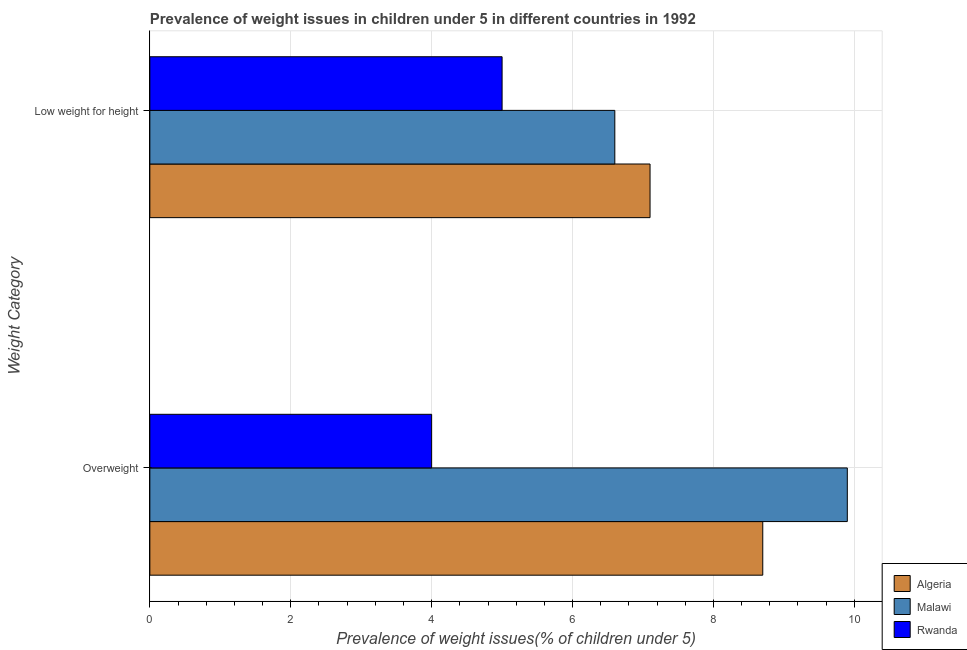How many different coloured bars are there?
Offer a terse response. 3. How many groups of bars are there?
Your answer should be very brief. 2. How many bars are there on the 2nd tick from the top?
Provide a succinct answer. 3. What is the label of the 1st group of bars from the top?
Provide a succinct answer. Low weight for height. What is the percentage of underweight children in Algeria?
Your answer should be compact. 7.1. Across all countries, what is the maximum percentage of underweight children?
Give a very brief answer. 7.1. Across all countries, what is the minimum percentage of overweight children?
Keep it short and to the point. 4. In which country was the percentage of underweight children maximum?
Offer a terse response. Algeria. In which country was the percentage of overweight children minimum?
Offer a terse response. Rwanda. What is the total percentage of underweight children in the graph?
Keep it short and to the point. 18.7. What is the difference between the percentage of overweight children in Rwanda and the percentage of underweight children in Algeria?
Keep it short and to the point. -3.1. What is the average percentage of underweight children per country?
Your answer should be very brief. 6.23. What is the difference between the percentage of overweight children and percentage of underweight children in Rwanda?
Give a very brief answer. -1. What is the ratio of the percentage of underweight children in Rwanda to that in Algeria?
Make the answer very short. 0.7. In how many countries, is the percentage of overweight children greater than the average percentage of overweight children taken over all countries?
Offer a very short reply. 2. What does the 3rd bar from the top in Overweight represents?
Your answer should be compact. Algeria. What does the 3rd bar from the bottom in Overweight represents?
Your answer should be very brief. Rwanda. What is the difference between two consecutive major ticks on the X-axis?
Provide a short and direct response. 2. How many legend labels are there?
Offer a terse response. 3. How are the legend labels stacked?
Offer a very short reply. Vertical. What is the title of the graph?
Your answer should be compact. Prevalence of weight issues in children under 5 in different countries in 1992. What is the label or title of the X-axis?
Keep it short and to the point. Prevalence of weight issues(% of children under 5). What is the label or title of the Y-axis?
Offer a very short reply. Weight Category. What is the Prevalence of weight issues(% of children under 5) of Algeria in Overweight?
Give a very brief answer. 8.7. What is the Prevalence of weight issues(% of children under 5) in Malawi in Overweight?
Keep it short and to the point. 9.9. What is the Prevalence of weight issues(% of children under 5) in Rwanda in Overweight?
Offer a very short reply. 4. What is the Prevalence of weight issues(% of children under 5) in Algeria in Low weight for height?
Provide a succinct answer. 7.1. What is the Prevalence of weight issues(% of children under 5) in Malawi in Low weight for height?
Your answer should be very brief. 6.6. Across all Weight Category, what is the maximum Prevalence of weight issues(% of children under 5) in Algeria?
Offer a very short reply. 8.7. Across all Weight Category, what is the maximum Prevalence of weight issues(% of children under 5) of Malawi?
Keep it short and to the point. 9.9. Across all Weight Category, what is the maximum Prevalence of weight issues(% of children under 5) in Rwanda?
Provide a succinct answer. 5. Across all Weight Category, what is the minimum Prevalence of weight issues(% of children under 5) in Algeria?
Your answer should be compact. 7.1. Across all Weight Category, what is the minimum Prevalence of weight issues(% of children under 5) of Malawi?
Make the answer very short. 6.6. Across all Weight Category, what is the minimum Prevalence of weight issues(% of children under 5) of Rwanda?
Your response must be concise. 4. What is the total Prevalence of weight issues(% of children under 5) of Algeria in the graph?
Offer a terse response. 15.8. What is the total Prevalence of weight issues(% of children under 5) of Malawi in the graph?
Offer a very short reply. 16.5. What is the total Prevalence of weight issues(% of children under 5) in Rwanda in the graph?
Your answer should be very brief. 9. What is the difference between the Prevalence of weight issues(% of children under 5) in Algeria in Overweight and that in Low weight for height?
Your answer should be very brief. 1.6. What is the difference between the Prevalence of weight issues(% of children under 5) in Malawi in Overweight and that in Low weight for height?
Provide a succinct answer. 3.3. What is the difference between the Prevalence of weight issues(% of children under 5) of Rwanda in Overweight and that in Low weight for height?
Offer a terse response. -1. What is the difference between the Prevalence of weight issues(% of children under 5) of Algeria in Overweight and the Prevalence of weight issues(% of children under 5) of Rwanda in Low weight for height?
Your answer should be very brief. 3.7. What is the difference between the Prevalence of weight issues(% of children under 5) of Malawi in Overweight and the Prevalence of weight issues(% of children under 5) of Rwanda in Low weight for height?
Offer a very short reply. 4.9. What is the average Prevalence of weight issues(% of children under 5) of Malawi per Weight Category?
Provide a succinct answer. 8.25. What is the average Prevalence of weight issues(% of children under 5) of Rwanda per Weight Category?
Provide a short and direct response. 4.5. What is the difference between the Prevalence of weight issues(% of children under 5) of Algeria and Prevalence of weight issues(% of children under 5) of Malawi in Overweight?
Your answer should be very brief. -1.2. What is the difference between the Prevalence of weight issues(% of children under 5) of Algeria and Prevalence of weight issues(% of children under 5) of Rwanda in Overweight?
Your answer should be very brief. 4.7. What is the difference between the Prevalence of weight issues(% of children under 5) of Malawi and Prevalence of weight issues(% of children under 5) of Rwanda in Overweight?
Make the answer very short. 5.9. What is the difference between the Prevalence of weight issues(% of children under 5) in Algeria and Prevalence of weight issues(% of children under 5) in Malawi in Low weight for height?
Offer a very short reply. 0.5. What is the difference between the Prevalence of weight issues(% of children under 5) in Algeria and Prevalence of weight issues(% of children under 5) in Rwanda in Low weight for height?
Provide a short and direct response. 2.1. What is the ratio of the Prevalence of weight issues(% of children under 5) in Algeria in Overweight to that in Low weight for height?
Ensure brevity in your answer.  1.23. What is the ratio of the Prevalence of weight issues(% of children under 5) in Rwanda in Overweight to that in Low weight for height?
Your response must be concise. 0.8. What is the difference between the highest and the second highest Prevalence of weight issues(% of children under 5) in Algeria?
Your answer should be compact. 1.6. What is the difference between the highest and the second highest Prevalence of weight issues(% of children under 5) in Malawi?
Your response must be concise. 3.3. What is the difference between the highest and the second highest Prevalence of weight issues(% of children under 5) in Rwanda?
Your answer should be compact. 1. What is the difference between the highest and the lowest Prevalence of weight issues(% of children under 5) of Algeria?
Give a very brief answer. 1.6. What is the difference between the highest and the lowest Prevalence of weight issues(% of children under 5) of Malawi?
Your answer should be compact. 3.3. What is the difference between the highest and the lowest Prevalence of weight issues(% of children under 5) of Rwanda?
Your response must be concise. 1. 